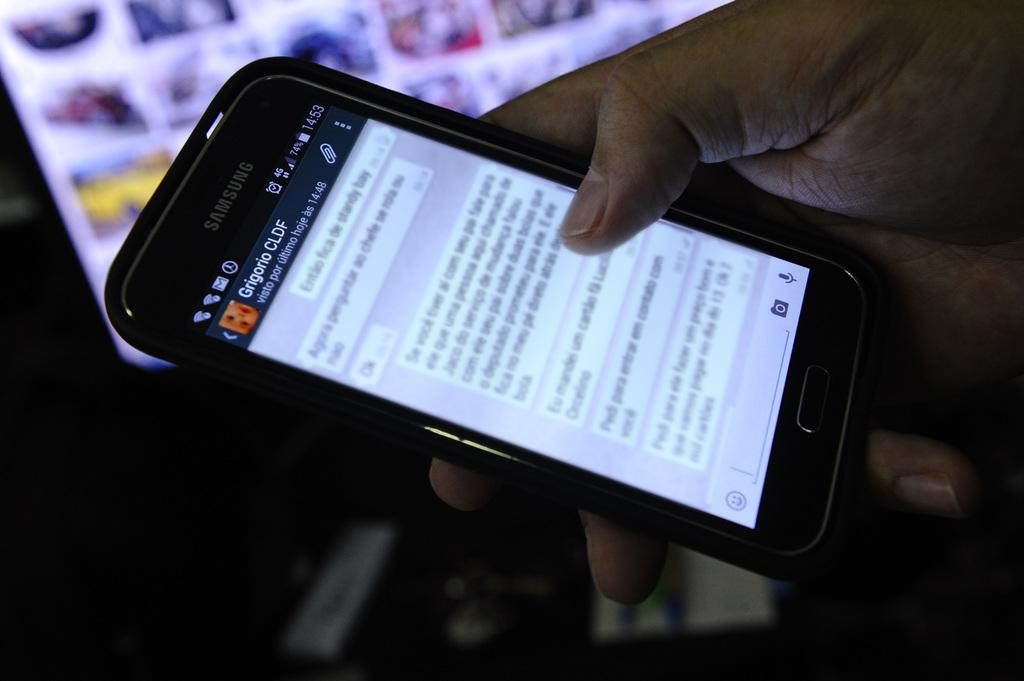What is the main subject in the foreground of the image? There is a person in the foreground of the image. What is the person holding in the image? The person is holding a mobile phone. What can be seen in the background of the image? There is a computer in the background of the image, along with other objects. How much salt is present on the person's hand in the image? There is no salt present on the person's hand in the image. What type of business is being conducted in the image? The image does not depict any business activities, as it primarily focuses on the person holding a mobile phone. 